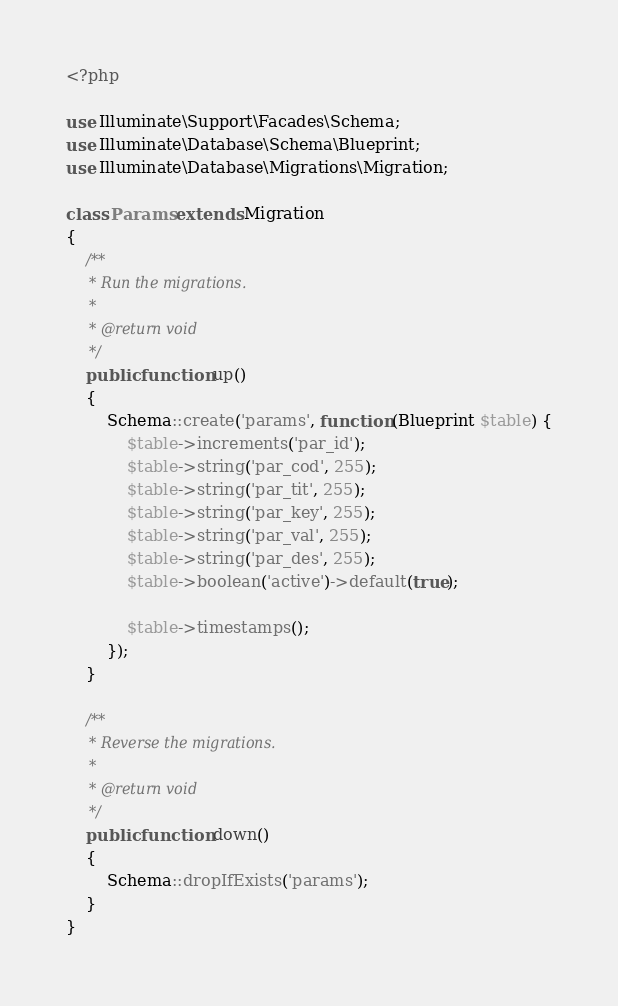<code> <loc_0><loc_0><loc_500><loc_500><_PHP_><?php

use Illuminate\Support\Facades\Schema;
use Illuminate\Database\Schema\Blueprint;
use Illuminate\Database\Migrations\Migration;

class Params extends Migration
{
    /**
     * Run the migrations.
     *
     * @return void
     */
    public function up()
    {
        Schema::create('params', function (Blueprint $table) {
            $table->increments('par_id');
            $table->string('par_cod', 255);
            $table->string('par_tit', 255);
            $table->string('par_key', 255);
            $table->string('par_val', 255);
            $table->string('par_des', 255);
            $table->boolean('active')->default(true);

            $table->timestamps();
        });
    }

    /**
     * Reverse the migrations.
     *
     * @return void
     */
    public function down()
    {
        Schema::dropIfExists('params');
    }
}
</code> 